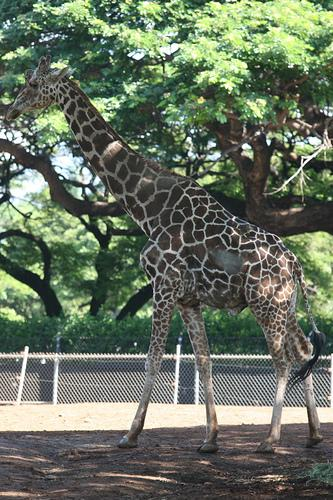What can you tell about the tail of the giraffe? The giraffe has a black furry tail that appears to be swishing. What kind of limbs can be seen on the giraffe in the image? All four of the giraffe's long legs and large hooves are visible. In a few words, describe the most prominent feature in the image. A giraffe in an enclosure with a dirt ground and wire fence. What type of fence is surrounding the giraffe's enclosure? A wire fence, possibly chain link, is surrounding the giraffe's enclosure. What is the ground like in the image? The ground is made of dirt in the image. What other color in the image can you identify apart from the giraffe? There is a light blue sky visible in the image. Can you tell what animal is the main focus of the image? The main focus of the image is a giraffe. Describe the main character's features and appearance. The giraffe has a brown and white coat, long legs, and a black furry tail with long black hairs. What kind of object provides shade for the giraffe in the image? A large tree branch casts a shadow on the ground to provide shade for the giraffe. What specific part of the giraffe is visible in the image? The left side of the giraffe is visible in the image. 